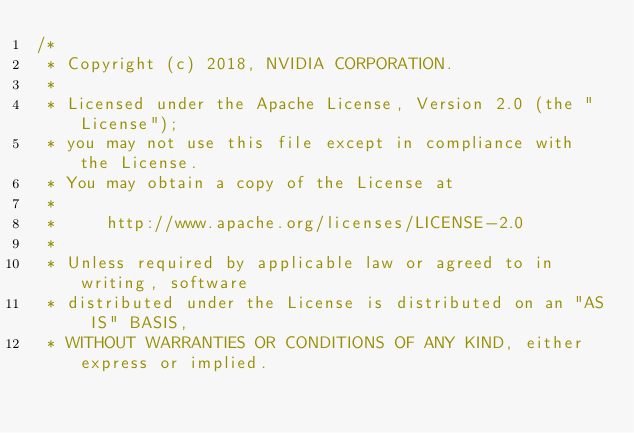Convert code to text. <code><loc_0><loc_0><loc_500><loc_500><_Cuda_>/*
 * Copyright (c) 2018, NVIDIA CORPORATION.
 *
 * Licensed under the Apache License, Version 2.0 (the "License");
 * you may not use this file except in compliance with the License.
 * You may obtain a copy of the License at
 *
 *     http://www.apache.org/licenses/LICENSE-2.0
 *
 * Unless required by applicable law or agreed to in writing, software
 * distributed under the License is distributed on an "AS IS" BASIS,
 * WITHOUT WARRANTIES OR CONDITIONS OF ANY KIND, either express or implied.</code> 